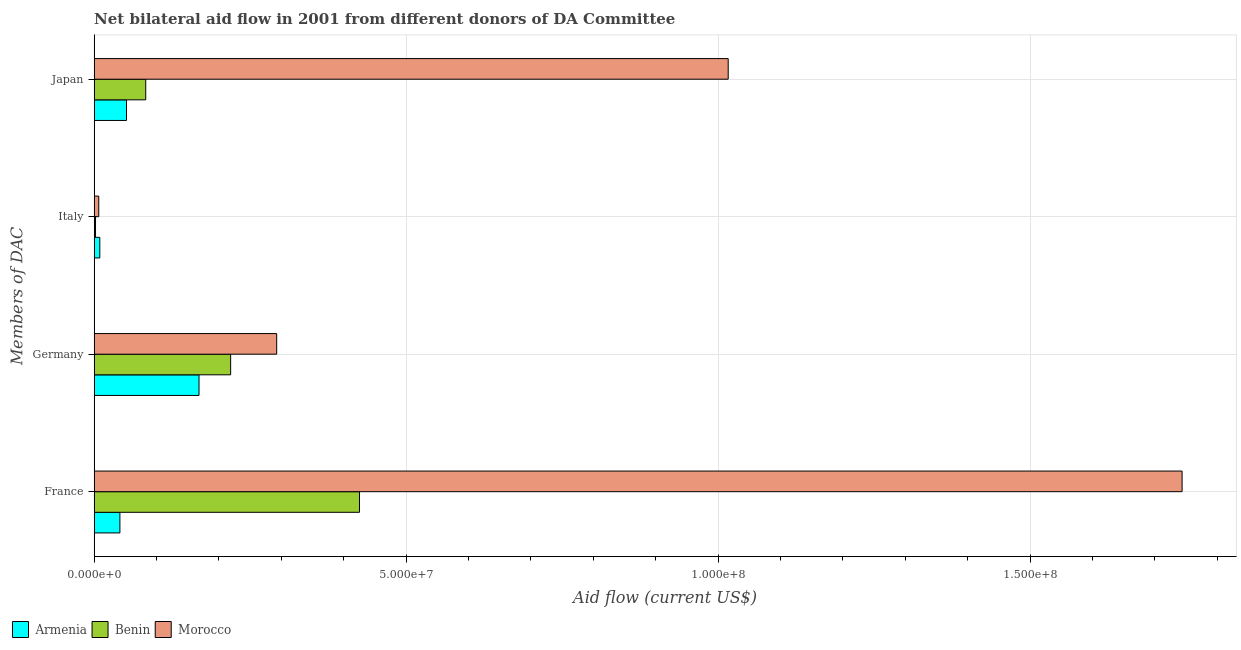How many bars are there on the 4th tick from the top?
Offer a terse response. 3. What is the amount of aid given by germany in Armenia?
Provide a succinct answer. 1.68e+07. Across all countries, what is the maximum amount of aid given by france?
Give a very brief answer. 1.74e+08. Across all countries, what is the minimum amount of aid given by italy?
Keep it short and to the point. 2.10e+05. In which country was the amount of aid given by france maximum?
Give a very brief answer. Morocco. In which country was the amount of aid given by france minimum?
Give a very brief answer. Armenia. What is the total amount of aid given by japan in the graph?
Offer a very short reply. 1.15e+08. What is the difference between the amount of aid given by japan in Morocco and that in Benin?
Give a very brief answer. 9.34e+07. What is the difference between the amount of aid given by germany in Armenia and the amount of aid given by france in Morocco?
Offer a terse response. -1.58e+08. What is the average amount of aid given by germany per country?
Offer a terse response. 2.26e+07. What is the difference between the amount of aid given by italy and amount of aid given by germany in Benin?
Give a very brief answer. -2.17e+07. What is the ratio of the amount of aid given by germany in Morocco to that in Armenia?
Your answer should be compact. 1.74. Is the amount of aid given by italy in Armenia less than that in Morocco?
Offer a terse response. No. What is the difference between the highest and the second highest amount of aid given by italy?
Ensure brevity in your answer.  1.70e+05. What is the difference between the highest and the lowest amount of aid given by france?
Give a very brief answer. 1.70e+08. In how many countries, is the amount of aid given by france greater than the average amount of aid given by france taken over all countries?
Keep it short and to the point. 1. What does the 2nd bar from the top in Germany represents?
Keep it short and to the point. Benin. What does the 1st bar from the bottom in Germany represents?
Make the answer very short. Armenia. Is it the case that in every country, the sum of the amount of aid given by france and amount of aid given by germany is greater than the amount of aid given by italy?
Make the answer very short. Yes. How many bars are there?
Provide a short and direct response. 12. Are all the bars in the graph horizontal?
Provide a succinct answer. Yes. What is the difference between two consecutive major ticks on the X-axis?
Give a very brief answer. 5.00e+07. Are the values on the major ticks of X-axis written in scientific E-notation?
Make the answer very short. Yes. How are the legend labels stacked?
Keep it short and to the point. Horizontal. What is the title of the graph?
Make the answer very short. Net bilateral aid flow in 2001 from different donors of DA Committee. What is the label or title of the Y-axis?
Keep it short and to the point. Members of DAC. What is the Aid flow (current US$) of Armenia in France?
Keep it short and to the point. 4.12e+06. What is the Aid flow (current US$) of Benin in France?
Keep it short and to the point. 4.25e+07. What is the Aid flow (current US$) in Morocco in France?
Give a very brief answer. 1.74e+08. What is the Aid flow (current US$) of Armenia in Germany?
Your response must be concise. 1.68e+07. What is the Aid flow (current US$) of Benin in Germany?
Ensure brevity in your answer.  2.19e+07. What is the Aid flow (current US$) of Morocco in Germany?
Offer a terse response. 2.92e+07. What is the Aid flow (current US$) of Armenia in Italy?
Your answer should be very brief. 9.00e+05. What is the Aid flow (current US$) of Morocco in Italy?
Your answer should be compact. 7.30e+05. What is the Aid flow (current US$) in Armenia in Japan?
Ensure brevity in your answer.  5.18e+06. What is the Aid flow (current US$) of Benin in Japan?
Keep it short and to the point. 8.26e+06. What is the Aid flow (current US$) of Morocco in Japan?
Provide a short and direct response. 1.02e+08. Across all Members of DAC, what is the maximum Aid flow (current US$) in Armenia?
Give a very brief answer. 1.68e+07. Across all Members of DAC, what is the maximum Aid flow (current US$) in Benin?
Your answer should be very brief. 4.25e+07. Across all Members of DAC, what is the maximum Aid flow (current US$) of Morocco?
Provide a short and direct response. 1.74e+08. Across all Members of DAC, what is the minimum Aid flow (current US$) in Morocco?
Ensure brevity in your answer.  7.30e+05. What is the total Aid flow (current US$) in Armenia in the graph?
Provide a succinct answer. 2.70e+07. What is the total Aid flow (current US$) in Benin in the graph?
Provide a succinct answer. 7.29e+07. What is the total Aid flow (current US$) of Morocco in the graph?
Provide a succinct answer. 3.06e+08. What is the difference between the Aid flow (current US$) of Armenia in France and that in Germany?
Your answer should be very brief. -1.27e+07. What is the difference between the Aid flow (current US$) in Benin in France and that in Germany?
Provide a short and direct response. 2.06e+07. What is the difference between the Aid flow (current US$) of Morocco in France and that in Germany?
Your answer should be very brief. 1.45e+08. What is the difference between the Aid flow (current US$) in Armenia in France and that in Italy?
Provide a succinct answer. 3.22e+06. What is the difference between the Aid flow (current US$) of Benin in France and that in Italy?
Offer a very short reply. 4.23e+07. What is the difference between the Aid flow (current US$) of Morocco in France and that in Italy?
Your response must be concise. 1.74e+08. What is the difference between the Aid flow (current US$) in Armenia in France and that in Japan?
Offer a very short reply. -1.06e+06. What is the difference between the Aid flow (current US$) in Benin in France and that in Japan?
Offer a terse response. 3.43e+07. What is the difference between the Aid flow (current US$) of Morocco in France and that in Japan?
Provide a short and direct response. 7.28e+07. What is the difference between the Aid flow (current US$) of Armenia in Germany and that in Italy?
Make the answer very short. 1.59e+07. What is the difference between the Aid flow (current US$) in Benin in Germany and that in Italy?
Your response must be concise. 2.17e+07. What is the difference between the Aid flow (current US$) of Morocco in Germany and that in Italy?
Offer a terse response. 2.85e+07. What is the difference between the Aid flow (current US$) in Armenia in Germany and that in Japan?
Ensure brevity in your answer.  1.16e+07. What is the difference between the Aid flow (current US$) of Benin in Germany and that in Japan?
Keep it short and to the point. 1.36e+07. What is the difference between the Aid flow (current US$) in Morocco in Germany and that in Japan?
Offer a terse response. -7.24e+07. What is the difference between the Aid flow (current US$) of Armenia in Italy and that in Japan?
Your response must be concise. -4.28e+06. What is the difference between the Aid flow (current US$) of Benin in Italy and that in Japan?
Offer a very short reply. -8.05e+06. What is the difference between the Aid flow (current US$) in Morocco in Italy and that in Japan?
Provide a short and direct response. -1.01e+08. What is the difference between the Aid flow (current US$) in Armenia in France and the Aid flow (current US$) in Benin in Germany?
Your answer should be very brief. -1.78e+07. What is the difference between the Aid flow (current US$) of Armenia in France and the Aid flow (current US$) of Morocco in Germany?
Offer a very short reply. -2.51e+07. What is the difference between the Aid flow (current US$) of Benin in France and the Aid flow (current US$) of Morocco in Germany?
Ensure brevity in your answer.  1.33e+07. What is the difference between the Aid flow (current US$) in Armenia in France and the Aid flow (current US$) in Benin in Italy?
Offer a terse response. 3.91e+06. What is the difference between the Aid flow (current US$) of Armenia in France and the Aid flow (current US$) of Morocco in Italy?
Provide a succinct answer. 3.39e+06. What is the difference between the Aid flow (current US$) in Benin in France and the Aid flow (current US$) in Morocco in Italy?
Your answer should be compact. 4.18e+07. What is the difference between the Aid flow (current US$) in Armenia in France and the Aid flow (current US$) in Benin in Japan?
Your answer should be compact. -4.14e+06. What is the difference between the Aid flow (current US$) of Armenia in France and the Aid flow (current US$) of Morocco in Japan?
Your answer should be very brief. -9.75e+07. What is the difference between the Aid flow (current US$) of Benin in France and the Aid flow (current US$) of Morocco in Japan?
Offer a terse response. -5.91e+07. What is the difference between the Aid flow (current US$) in Armenia in Germany and the Aid flow (current US$) in Benin in Italy?
Provide a succinct answer. 1.66e+07. What is the difference between the Aid flow (current US$) in Armenia in Germany and the Aid flow (current US$) in Morocco in Italy?
Give a very brief answer. 1.61e+07. What is the difference between the Aid flow (current US$) of Benin in Germany and the Aid flow (current US$) of Morocco in Italy?
Offer a terse response. 2.11e+07. What is the difference between the Aid flow (current US$) in Armenia in Germany and the Aid flow (current US$) in Benin in Japan?
Give a very brief answer. 8.54e+06. What is the difference between the Aid flow (current US$) of Armenia in Germany and the Aid flow (current US$) of Morocco in Japan?
Your answer should be compact. -8.48e+07. What is the difference between the Aid flow (current US$) in Benin in Germany and the Aid flow (current US$) in Morocco in Japan?
Your response must be concise. -7.98e+07. What is the difference between the Aid flow (current US$) of Armenia in Italy and the Aid flow (current US$) of Benin in Japan?
Your response must be concise. -7.36e+06. What is the difference between the Aid flow (current US$) of Armenia in Italy and the Aid flow (current US$) of Morocco in Japan?
Your answer should be very brief. -1.01e+08. What is the difference between the Aid flow (current US$) of Benin in Italy and the Aid flow (current US$) of Morocco in Japan?
Give a very brief answer. -1.01e+08. What is the average Aid flow (current US$) of Armenia per Members of DAC?
Your answer should be compact. 6.75e+06. What is the average Aid flow (current US$) of Benin per Members of DAC?
Keep it short and to the point. 1.82e+07. What is the average Aid flow (current US$) of Morocco per Members of DAC?
Offer a terse response. 7.65e+07. What is the difference between the Aid flow (current US$) in Armenia and Aid flow (current US$) in Benin in France?
Your answer should be compact. -3.84e+07. What is the difference between the Aid flow (current US$) in Armenia and Aid flow (current US$) in Morocco in France?
Give a very brief answer. -1.70e+08. What is the difference between the Aid flow (current US$) in Benin and Aid flow (current US$) in Morocco in France?
Provide a short and direct response. -1.32e+08. What is the difference between the Aid flow (current US$) in Armenia and Aid flow (current US$) in Benin in Germany?
Keep it short and to the point. -5.07e+06. What is the difference between the Aid flow (current US$) of Armenia and Aid flow (current US$) of Morocco in Germany?
Your response must be concise. -1.24e+07. What is the difference between the Aid flow (current US$) in Benin and Aid flow (current US$) in Morocco in Germany?
Provide a short and direct response. -7.38e+06. What is the difference between the Aid flow (current US$) of Armenia and Aid flow (current US$) of Benin in Italy?
Your answer should be very brief. 6.90e+05. What is the difference between the Aid flow (current US$) of Armenia and Aid flow (current US$) of Morocco in Italy?
Make the answer very short. 1.70e+05. What is the difference between the Aid flow (current US$) in Benin and Aid flow (current US$) in Morocco in Italy?
Offer a terse response. -5.20e+05. What is the difference between the Aid flow (current US$) in Armenia and Aid flow (current US$) in Benin in Japan?
Your answer should be compact. -3.08e+06. What is the difference between the Aid flow (current US$) of Armenia and Aid flow (current US$) of Morocco in Japan?
Your answer should be very brief. -9.64e+07. What is the difference between the Aid flow (current US$) of Benin and Aid flow (current US$) of Morocco in Japan?
Keep it short and to the point. -9.34e+07. What is the ratio of the Aid flow (current US$) of Armenia in France to that in Germany?
Provide a succinct answer. 0.25. What is the ratio of the Aid flow (current US$) in Benin in France to that in Germany?
Your answer should be very brief. 1.94. What is the ratio of the Aid flow (current US$) in Morocco in France to that in Germany?
Ensure brevity in your answer.  5.96. What is the ratio of the Aid flow (current US$) of Armenia in France to that in Italy?
Offer a very short reply. 4.58. What is the ratio of the Aid flow (current US$) in Benin in France to that in Italy?
Offer a very short reply. 202.48. What is the ratio of the Aid flow (current US$) in Morocco in France to that in Italy?
Keep it short and to the point. 238.86. What is the ratio of the Aid flow (current US$) of Armenia in France to that in Japan?
Your answer should be compact. 0.8. What is the ratio of the Aid flow (current US$) in Benin in France to that in Japan?
Make the answer very short. 5.15. What is the ratio of the Aid flow (current US$) in Morocco in France to that in Japan?
Your response must be concise. 1.72. What is the ratio of the Aid flow (current US$) of Armenia in Germany to that in Italy?
Give a very brief answer. 18.67. What is the ratio of the Aid flow (current US$) in Benin in Germany to that in Italy?
Give a very brief answer. 104.14. What is the ratio of the Aid flow (current US$) of Morocco in Germany to that in Italy?
Keep it short and to the point. 40.07. What is the ratio of the Aid flow (current US$) in Armenia in Germany to that in Japan?
Ensure brevity in your answer.  3.24. What is the ratio of the Aid flow (current US$) in Benin in Germany to that in Japan?
Give a very brief answer. 2.65. What is the ratio of the Aid flow (current US$) of Morocco in Germany to that in Japan?
Your response must be concise. 0.29. What is the ratio of the Aid flow (current US$) of Armenia in Italy to that in Japan?
Make the answer very short. 0.17. What is the ratio of the Aid flow (current US$) in Benin in Italy to that in Japan?
Provide a short and direct response. 0.03. What is the ratio of the Aid flow (current US$) of Morocco in Italy to that in Japan?
Make the answer very short. 0.01. What is the difference between the highest and the second highest Aid flow (current US$) in Armenia?
Provide a short and direct response. 1.16e+07. What is the difference between the highest and the second highest Aid flow (current US$) of Benin?
Your answer should be compact. 2.06e+07. What is the difference between the highest and the second highest Aid flow (current US$) in Morocco?
Make the answer very short. 7.28e+07. What is the difference between the highest and the lowest Aid flow (current US$) in Armenia?
Ensure brevity in your answer.  1.59e+07. What is the difference between the highest and the lowest Aid flow (current US$) of Benin?
Provide a short and direct response. 4.23e+07. What is the difference between the highest and the lowest Aid flow (current US$) of Morocco?
Offer a terse response. 1.74e+08. 